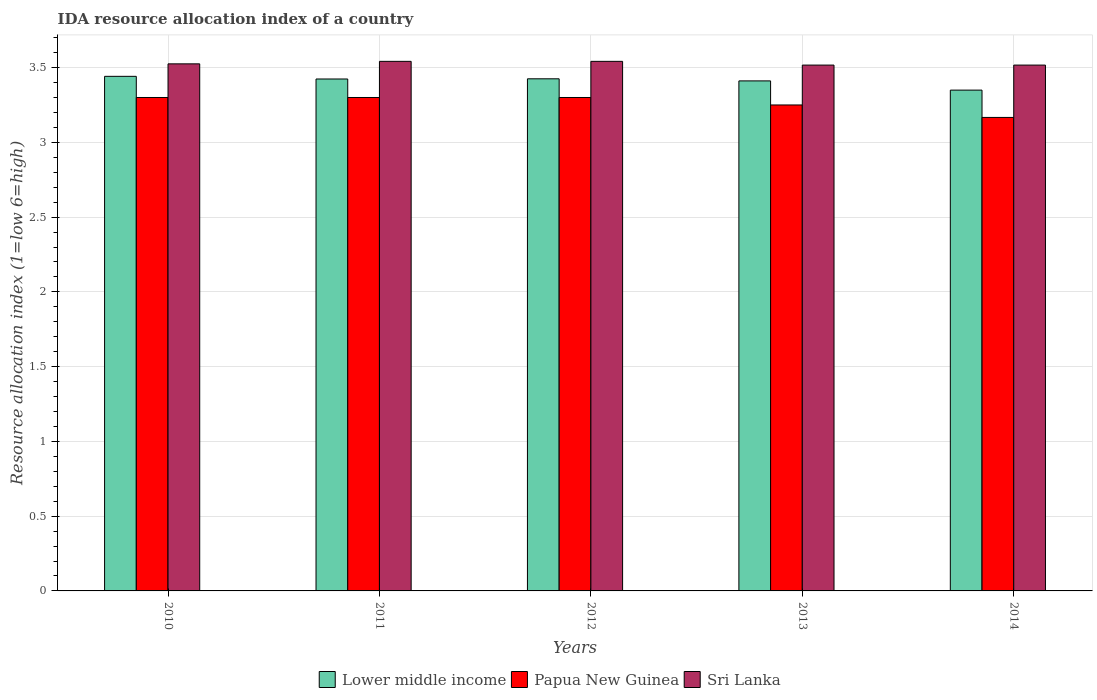How many different coloured bars are there?
Your response must be concise. 3. How many groups of bars are there?
Your response must be concise. 5. Are the number of bars per tick equal to the number of legend labels?
Give a very brief answer. Yes. Are the number of bars on each tick of the X-axis equal?
Provide a short and direct response. Yes. How many bars are there on the 4th tick from the right?
Give a very brief answer. 3. What is the IDA resource allocation index in Lower middle income in 2010?
Offer a terse response. 3.44. Across all years, what is the maximum IDA resource allocation index in Sri Lanka?
Ensure brevity in your answer.  3.54. Across all years, what is the minimum IDA resource allocation index in Lower middle income?
Give a very brief answer. 3.35. In which year was the IDA resource allocation index in Sri Lanka minimum?
Your answer should be compact. 2013. What is the total IDA resource allocation index in Papua New Guinea in the graph?
Provide a succinct answer. 16.32. What is the difference between the IDA resource allocation index in Papua New Guinea in 2010 and that in 2014?
Your answer should be compact. 0.13. What is the difference between the IDA resource allocation index in Lower middle income in 2011 and the IDA resource allocation index in Papua New Guinea in 2014?
Offer a terse response. 0.26. What is the average IDA resource allocation index in Lower middle income per year?
Ensure brevity in your answer.  3.41. In the year 2014, what is the difference between the IDA resource allocation index in Lower middle income and IDA resource allocation index in Sri Lanka?
Keep it short and to the point. -0.17. What is the ratio of the IDA resource allocation index in Sri Lanka in 2011 to that in 2013?
Provide a succinct answer. 1.01. Is the IDA resource allocation index in Sri Lanka in 2012 less than that in 2013?
Ensure brevity in your answer.  No. Is the difference between the IDA resource allocation index in Lower middle income in 2010 and 2012 greater than the difference between the IDA resource allocation index in Sri Lanka in 2010 and 2012?
Offer a terse response. Yes. What is the difference between the highest and the second highest IDA resource allocation index in Sri Lanka?
Give a very brief answer. 0. What is the difference between the highest and the lowest IDA resource allocation index in Sri Lanka?
Your answer should be very brief. 0.02. In how many years, is the IDA resource allocation index in Lower middle income greater than the average IDA resource allocation index in Lower middle income taken over all years?
Provide a short and direct response. 4. Is the sum of the IDA resource allocation index in Papua New Guinea in 2011 and 2013 greater than the maximum IDA resource allocation index in Lower middle income across all years?
Ensure brevity in your answer.  Yes. What does the 3rd bar from the left in 2010 represents?
Offer a very short reply. Sri Lanka. What does the 3rd bar from the right in 2014 represents?
Provide a succinct answer. Lower middle income. Are all the bars in the graph horizontal?
Ensure brevity in your answer.  No. What is the difference between two consecutive major ticks on the Y-axis?
Provide a succinct answer. 0.5. How many legend labels are there?
Keep it short and to the point. 3. What is the title of the graph?
Make the answer very short. IDA resource allocation index of a country. Does "Bahrain" appear as one of the legend labels in the graph?
Your response must be concise. No. What is the label or title of the Y-axis?
Your answer should be compact. Resource allocation index (1=low 6=high). What is the Resource allocation index (1=low 6=high) of Lower middle income in 2010?
Ensure brevity in your answer.  3.44. What is the Resource allocation index (1=low 6=high) of Sri Lanka in 2010?
Your answer should be compact. 3.52. What is the Resource allocation index (1=low 6=high) of Lower middle income in 2011?
Offer a terse response. 3.42. What is the Resource allocation index (1=low 6=high) in Papua New Guinea in 2011?
Your answer should be compact. 3.3. What is the Resource allocation index (1=low 6=high) of Sri Lanka in 2011?
Your response must be concise. 3.54. What is the Resource allocation index (1=low 6=high) of Lower middle income in 2012?
Give a very brief answer. 3.42. What is the Resource allocation index (1=low 6=high) in Sri Lanka in 2012?
Your response must be concise. 3.54. What is the Resource allocation index (1=low 6=high) of Lower middle income in 2013?
Offer a terse response. 3.41. What is the Resource allocation index (1=low 6=high) of Sri Lanka in 2013?
Give a very brief answer. 3.52. What is the Resource allocation index (1=low 6=high) of Lower middle income in 2014?
Make the answer very short. 3.35. What is the Resource allocation index (1=low 6=high) in Papua New Guinea in 2014?
Make the answer very short. 3.17. What is the Resource allocation index (1=low 6=high) in Sri Lanka in 2014?
Provide a short and direct response. 3.52. Across all years, what is the maximum Resource allocation index (1=low 6=high) in Lower middle income?
Provide a succinct answer. 3.44. Across all years, what is the maximum Resource allocation index (1=low 6=high) of Sri Lanka?
Make the answer very short. 3.54. Across all years, what is the minimum Resource allocation index (1=low 6=high) in Lower middle income?
Your answer should be compact. 3.35. Across all years, what is the minimum Resource allocation index (1=low 6=high) in Papua New Guinea?
Offer a terse response. 3.17. Across all years, what is the minimum Resource allocation index (1=low 6=high) in Sri Lanka?
Provide a short and direct response. 3.52. What is the total Resource allocation index (1=low 6=high) in Lower middle income in the graph?
Your answer should be very brief. 17.05. What is the total Resource allocation index (1=low 6=high) in Papua New Guinea in the graph?
Keep it short and to the point. 16.32. What is the total Resource allocation index (1=low 6=high) of Sri Lanka in the graph?
Your answer should be very brief. 17.64. What is the difference between the Resource allocation index (1=low 6=high) of Lower middle income in 2010 and that in 2011?
Offer a very short reply. 0.02. What is the difference between the Resource allocation index (1=low 6=high) in Sri Lanka in 2010 and that in 2011?
Provide a short and direct response. -0.02. What is the difference between the Resource allocation index (1=low 6=high) of Lower middle income in 2010 and that in 2012?
Give a very brief answer. 0.02. What is the difference between the Resource allocation index (1=low 6=high) of Sri Lanka in 2010 and that in 2012?
Keep it short and to the point. -0.02. What is the difference between the Resource allocation index (1=low 6=high) of Lower middle income in 2010 and that in 2013?
Provide a short and direct response. 0.03. What is the difference between the Resource allocation index (1=low 6=high) in Papua New Guinea in 2010 and that in 2013?
Your answer should be compact. 0.05. What is the difference between the Resource allocation index (1=low 6=high) in Sri Lanka in 2010 and that in 2013?
Provide a short and direct response. 0.01. What is the difference between the Resource allocation index (1=low 6=high) in Lower middle income in 2010 and that in 2014?
Provide a short and direct response. 0.09. What is the difference between the Resource allocation index (1=low 6=high) in Papua New Guinea in 2010 and that in 2014?
Make the answer very short. 0.13. What is the difference between the Resource allocation index (1=low 6=high) in Sri Lanka in 2010 and that in 2014?
Provide a short and direct response. 0.01. What is the difference between the Resource allocation index (1=low 6=high) of Lower middle income in 2011 and that in 2012?
Make the answer very short. -0. What is the difference between the Resource allocation index (1=low 6=high) in Lower middle income in 2011 and that in 2013?
Offer a terse response. 0.01. What is the difference between the Resource allocation index (1=low 6=high) in Sri Lanka in 2011 and that in 2013?
Give a very brief answer. 0.03. What is the difference between the Resource allocation index (1=low 6=high) in Lower middle income in 2011 and that in 2014?
Make the answer very short. 0.07. What is the difference between the Resource allocation index (1=low 6=high) of Papua New Guinea in 2011 and that in 2014?
Your answer should be compact. 0.13. What is the difference between the Resource allocation index (1=low 6=high) in Sri Lanka in 2011 and that in 2014?
Provide a succinct answer. 0.03. What is the difference between the Resource allocation index (1=low 6=high) in Lower middle income in 2012 and that in 2013?
Ensure brevity in your answer.  0.01. What is the difference between the Resource allocation index (1=low 6=high) of Sri Lanka in 2012 and that in 2013?
Keep it short and to the point. 0.03. What is the difference between the Resource allocation index (1=low 6=high) in Lower middle income in 2012 and that in 2014?
Offer a terse response. 0.08. What is the difference between the Resource allocation index (1=low 6=high) in Papua New Guinea in 2012 and that in 2014?
Ensure brevity in your answer.  0.13. What is the difference between the Resource allocation index (1=low 6=high) of Sri Lanka in 2012 and that in 2014?
Offer a very short reply. 0.03. What is the difference between the Resource allocation index (1=low 6=high) in Lower middle income in 2013 and that in 2014?
Give a very brief answer. 0.06. What is the difference between the Resource allocation index (1=low 6=high) in Papua New Guinea in 2013 and that in 2014?
Offer a terse response. 0.08. What is the difference between the Resource allocation index (1=low 6=high) of Lower middle income in 2010 and the Resource allocation index (1=low 6=high) of Papua New Guinea in 2011?
Keep it short and to the point. 0.14. What is the difference between the Resource allocation index (1=low 6=high) in Lower middle income in 2010 and the Resource allocation index (1=low 6=high) in Sri Lanka in 2011?
Offer a very short reply. -0.1. What is the difference between the Resource allocation index (1=low 6=high) of Papua New Guinea in 2010 and the Resource allocation index (1=low 6=high) of Sri Lanka in 2011?
Make the answer very short. -0.24. What is the difference between the Resource allocation index (1=low 6=high) of Lower middle income in 2010 and the Resource allocation index (1=low 6=high) of Papua New Guinea in 2012?
Provide a short and direct response. 0.14. What is the difference between the Resource allocation index (1=low 6=high) of Lower middle income in 2010 and the Resource allocation index (1=low 6=high) of Sri Lanka in 2012?
Make the answer very short. -0.1. What is the difference between the Resource allocation index (1=low 6=high) of Papua New Guinea in 2010 and the Resource allocation index (1=low 6=high) of Sri Lanka in 2012?
Your answer should be very brief. -0.24. What is the difference between the Resource allocation index (1=low 6=high) of Lower middle income in 2010 and the Resource allocation index (1=low 6=high) of Papua New Guinea in 2013?
Your response must be concise. 0.19. What is the difference between the Resource allocation index (1=low 6=high) of Lower middle income in 2010 and the Resource allocation index (1=low 6=high) of Sri Lanka in 2013?
Offer a terse response. -0.08. What is the difference between the Resource allocation index (1=low 6=high) in Papua New Guinea in 2010 and the Resource allocation index (1=low 6=high) in Sri Lanka in 2013?
Give a very brief answer. -0.22. What is the difference between the Resource allocation index (1=low 6=high) in Lower middle income in 2010 and the Resource allocation index (1=low 6=high) in Papua New Guinea in 2014?
Your answer should be very brief. 0.27. What is the difference between the Resource allocation index (1=low 6=high) of Lower middle income in 2010 and the Resource allocation index (1=low 6=high) of Sri Lanka in 2014?
Ensure brevity in your answer.  -0.08. What is the difference between the Resource allocation index (1=low 6=high) in Papua New Guinea in 2010 and the Resource allocation index (1=low 6=high) in Sri Lanka in 2014?
Provide a succinct answer. -0.22. What is the difference between the Resource allocation index (1=low 6=high) of Lower middle income in 2011 and the Resource allocation index (1=low 6=high) of Papua New Guinea in 2012?
Your answer should be very brief. 0.12. What is the difference between the Resource allocation index (1=low 6=high) in Lower middle income in 2011 and the Resource allocation index (1=low 6=high) in Sri Lanka in 2012?
Keep it short and to the point. -0.12. What is the difference between the Resource allocation index (1=low 6=high) of Papua New Guinea in 2011 and the Resource allocation index (1=low 6=high) of Sri Lanka in 2012?
Keep it short and to the point. -0.24. What is the difference between the Resource allocation index (1=low 6=high) in Lower middle income in 2011 and the Resource allocation index (1=low 6=high) in Papua New Guinea in 2013?
Keep it short and to the point. 0.17. What is the difference between the Resource allocation index (1=low 6=high) of Lower middle income in 2011 and the Resource allocation index (1=low 6=high) of Sri Lanka in 2013?
Your response must be concise. -0.09. What is the difference between the Resource allocation index (1=low 6=high) of Papua New Guinea in 2011 and the Resource allocation index (1=low 6=high) of Sri Lanka in 2013?
Make the answer very short. -0.22. What is the difference between the Resource allocation index (1=low 6=high) in Lower middle income in 2011 and the Resource allocation index (1=low 6=high) in Papua New Guinea in 2014?
Provide a succinct answer. 0.26. What is the difference between the Resource allocation index (1=low 6=high) in Lower middle income in 2011 and the Resource allocation index (1=low 6=high) in Sri Lanka in 2014?
Provide a short and direct response. -0.09. What is the difference between the Resource allocation index (1=low 6=high) of Papua New Guinea in 2011 and the Resource allocation index (1=low 6=high) of Sri Lanka in 2014?
Your answer should be compact. -0.22. What is the difference between the Resource allocation index (1=low 6=high) of Lower middle income in 2012 and the Resource allocation index (1=low 6=high) of Papua New Guinea in 2013?
Ensure brevity in your answer.  0.17. What is the difference between the Resource allocation index (1=low 6=high) in Lower middle income in 2012 and the Resource allocation index (1=low 6=high) in Sri Lanka in 2013?
Provide a succinct answer. -0.09. What is the difference between the Resource allocation index (1=low 6=high) in Papua New Guinea in 2012 and the Resource allocation index (1=low 6=high) in Sri Lanka in 2013?
Provide a succinct answer. -0.22. What is the difference between the Resource allocation index (1=low 6=high) of Lower middle income in 2012 and the Resource allocation index (1=low 6=high) of Papua New Guinea in 2014?
Give a very brief answer. 0.26. What is the difference between the Resource allocation index (1=low 6=high) of Lower middle income in 2012 and the Resource allocation index (1=low 6=high) of Sri Lanka in 2014?
Make the answer very short. -0.09. What is the difference between the Resource allocation index (1=low 6=high) in Papua New Guinea in 2012 and the Resource allocation index (1=low 6=high) in Sri Lanka in 2014?
Make the answer very short. -0.22. What is the difference between the Resource allocation index (1=low 6=high) of Lower middle income in 2013 and the Resource allocation index (1=low 6=high) of Papua New Guinea in 2014?
Make the answer very short. 0.24. What is the difference between the Resource allocation index (1=low 6=high) of Lower middle income in 2013 and the Resource allocation index (1=low 6=high) of Sri Lanka in 2014?
Provide a short and direct response. -0.11. What is the difference between the Resource allocation index (1=low 6=high) in Papua New Guinea in 2013 and the Resource allocation index (1=low 6=high) in Sri Lanka in 2014?
Your answer should be very brief. -0.27. What is the average Resource allocation index (1=low 6=high) of Lower middle income per year?
Your response must be concise. 3.41. What is the average Resource allocation index (1=low 6=high) in Papua New Guinea per year?
Provide a succinct answer. 3.26. What is the average Resource allocation index (1=low 6=high) in Sri Lanka per year?
Provide a succinct answer. 3.53. In the year 2010, what is the difference between the Resource allocation index (1=low 6=high) in Lower middle income and Resource allocation index (1=low 6=high) in Papua New Guinea?
Provide a succinct answer. 0.14. In the year 2010, what is the difference between the Resource allocation index (1=low 6=high) in Lower middle income and Resource allocation index (1=low 6=high) in Sri Lanka?
Keep it short and to the point. -0.08. In the year 2010, what is the difference between the Resource allocation index (1=low 6=high) in Papua New Guinea and Resource allocation index (1=low 6=high) in Sri Lanka?
Provide a short and direct response. -0.23. In the year 2011, what is the difference between the Resource allocation index (1=low 6=high) in Lower middle income and Resource allocation index (1=low 6=high) in Papua New Guinea?
Make the answer very short. 0.12. In the year 2011, what is the difference between the Resource allocation index (1=low 6=high) of Lower middle income and Resource allocation index (1=low 6=high) of Sri Lanka?
Keep it short and to the point. -0.12. In the year 2011, what is the difference between the Resource allocation index (1=low 6=high) in Papua New Guinea and Resource allocation index (1=low 6=high) in Sri Lanka?
Offer a very short reply. -0.24. In the year 2012, what is the difference between the Resource allocation index (1=low 6=high) of Lower middle income and Resource allocation index (1=low 6=high) of Sri Lanka?
Provide a succinct answer. -0.12. In the year 2012, what is the difference between the Resource allocation index (1=low 6=high) in Papua New Guinea and Resource allocation index (1=low 6=high) in Sri Lanka?
Provide a succinct answer. -0.24. In the year 2013, what is the difference between the Resource allocation index (1=low 6=high) in Lower middle income and Resource allocation index (1=low 6=high) in Papua New Guinea?
Give a very brief answer. 0.16. In the year 2013, what is the difference between the Resource allocation index (1=low 6=high) of Lower middle income and Resource allocation index (1=low 6=high) of Sri Lanka?
Your answer should be compact. -0.11. In the year 2013, what is the difference between the Resource allocation index (1=low 6=high) of Papua New Guinea and Resource allocation index (1=low 6=high) of Sri Lanka?
Give a very brief answer. -0.27. In the year 2014, what is the difference between the Resource allocation index (1=low 6=high) of Lower middle income and Resource allocation index (1=low 6=high) of Papua New Guinea?
Ensure brevity in your answer.  0.18. In the year 2014, what is the difference between the Resource allocation index (1=low 6=high) in Lower middle income and Resource allocation index (1=low 6=high) in Sri Lanka?
Provide a short and direct response. -0.17. In the year 2014, what is the difference between the Resource allocation index (1=low 6=high) of Papua New Guinea and Resource allocation index (1=low 6=high) of Sri Lanka?
Offer a very short reply. -0.35. What is the ratio of the Resource allocation index (1=low 6=high) in Sri Lanka in 2010 to that in 2011?
Make the answer very short. 1. What is the ratio of the Resource allocation index (1=low 6=high) in Papua New Guinea in 2010 to that in 2012?
Your response must be concise. 1. What is the ratio of the Resource allocation index (1=low 6=high) in Lower middle income in 2010 to that in 2013?
Your answer should be very brief. 1.01. What is the ratio of the Resource allocation index (1=low 6=high) in Papua New Guinea in 2010 to that in 2013?
Keep it short and to the point. 1.02. What is the ratio of the Resource allocation index (1=low 6=high) of Lower middle income in 2010 to that in 2014?
Offer a terse response. 1.03. What is the ratio of the Resource allocation index (1=low 6=high) of Papua New Guinea in 2010 to that in 2014?
Your answer should be compact. 1.04. What is the ratio of the Resource allocation index (1=low 6=high) in Lower middle income in 2011 to that in 2012?
Provide a succinct answer. 1. What is the ratio of the Resource allocation index (1=low 6=high) of Papua New Guinea in 2011 to that in 2013?
Ensure brevity in your answer.  1.02. What is the ratio of the Resource allocation index (1=low 6=high) in Sri Lanka in 2011 to that in 2013?
Provide a succinct answer. 1.01. What is the ratio of the Resource allocation index (1=low 6=high) of Lower middle income in 2011 to that in 2014?
Provide a succinct answer. 1.02. What is the ratio of the Resource allocation index (1=low 6=high) in Papua New Guinea in 2011 to that in 2014?
Provide a succinct answer. 1.04. What is the ratio of the Resource allocation index (1=low 6=high) of Sri Lanka in 2011 to that in 2014?
Ensure brevity in your answer.  1.01. What is the ratio of the Resource allocation index (1=low 6=high) of Lower middle income in 2012 to that in 2013?
Ensure brevity in your answer.  1. What is the ratio of the Resource allocation index (1=low 6=high) of Papua New Guinea in 2012 to that in 2013?
Offer a very short reply. 1.02. What is the ratio of the Resource allocation index (1=low 6=high) of Sri Lanka in 2012 to that in 2013?
Your answer should be very brief. 1.01. What is the ratio of the Resource allocation index (1=low 6=high) in Lower middle income in 2012 to that in 2014?
Provide a short and direct response. 1.02. What is the ratio of the Resource allocation index (1=low 6=high) of Papua New Guinea in 2012 to that in 2014?
Your answer should be compact. 1.04. What is the ratio of the Resource allocation index (1=low 6=high) of Sri Lanka in 2012 to that in 2014?
Give a very brief answer. 1.01. What is the ratio of the Resource allocation index (1=low 6=high) of Lower middle income in 2013 to that in 2014?
Give a very brief answer. 1.02. What is the ratio of the Resource allocation index (1=low 6=high) in Papua New Guinea in 2013 to that in 2014?
Ensure brevity in your answer.  1.03. What is the ratio of the Resource allocation index (1=low 6=high) of Sri Lanka in 2013 to that in 2014?
Keep it short and to the point. 1. What is the difference between the highest and the second highest Resource allocation index (1=low 6=high) of Lower middle income?
Provide a succinct answer. 0.02. What is the difference between the highest and the second highest Resource allocation index (1=low 6=high) of Papua New Guinea?
Make the answer very short. 0. What is the difference between the highest and the second highest Resource allocation index (1=low 6=high) in Sri Lanka?
Your response must be concise. 0. What is the difference between the highest and the lowest Resource allocation index (1=low 6=high) in Lower middle income?
Your answer should be compact. 0.09. What is the difference between the highest and the lowest Resource allocation index (1=low 6=high) of Papua New Guinea?
Your answer should be compact. 0.13. What is the difference between the highest and the lowest Resource allocation index (1=low 6=high) of Sri Lanka?
Your answer should be very brief. 0.03. 